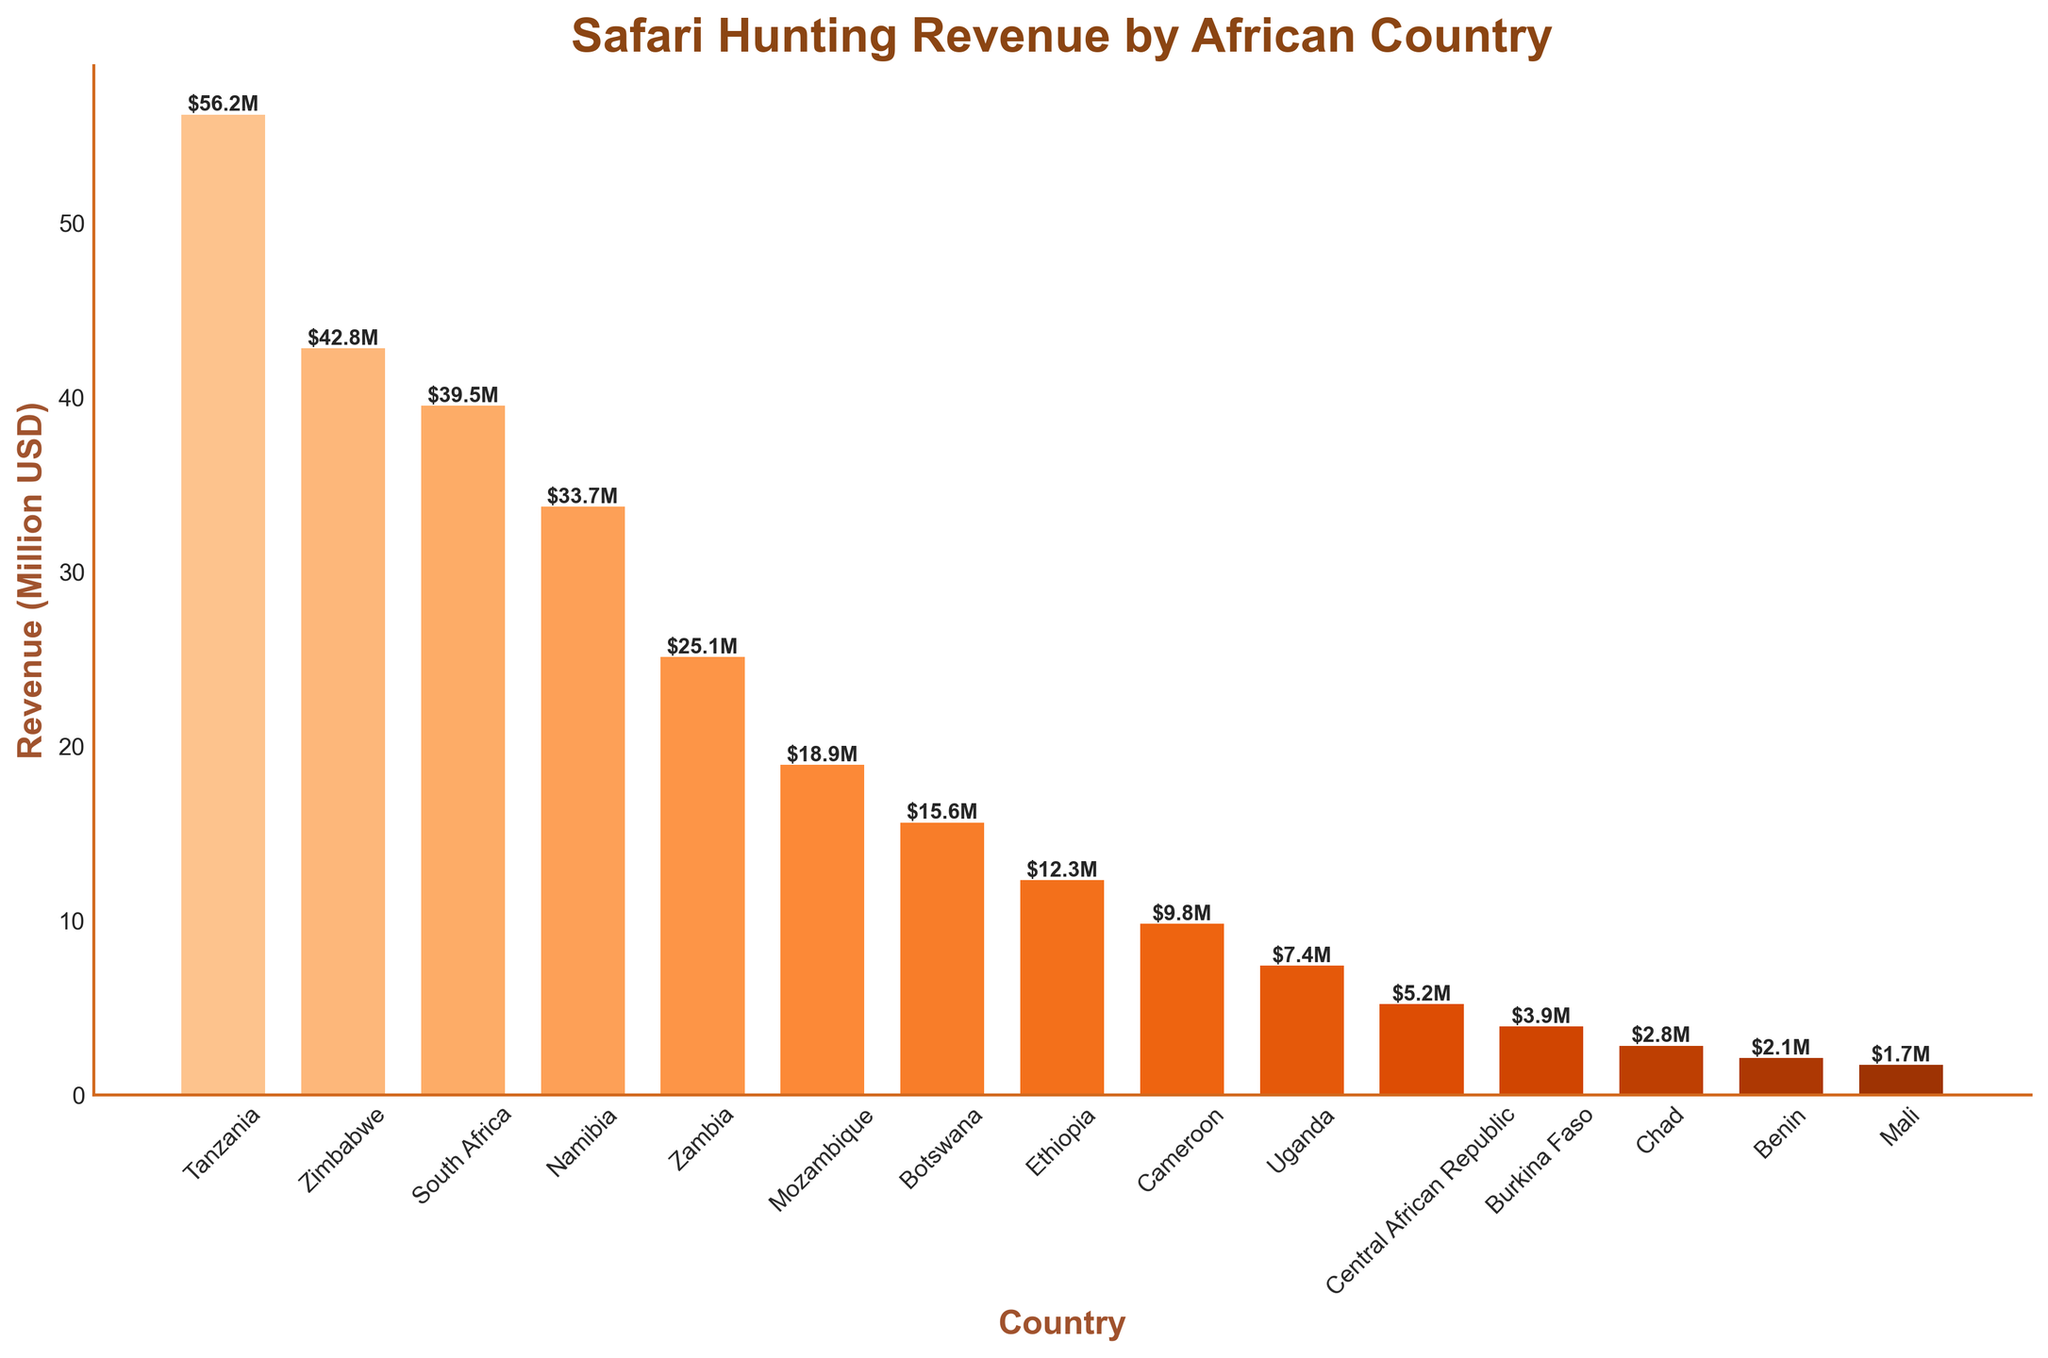Why is Tanzania's bar the tallest? Tanzania's bar is the tallest because it has the highest Safari Hunting Revenue among the listed African countries. According to the data, Tanzania's revenue is 56.2 million USD, which is the largest value in the dataset.
Answer: It has the highest revenue Which country has the lowest safari hunting revenue? The country with the shortest bar represents the lowest safari hunting revenue. According to the data, Mali has the lowest revenue of 1.7 million USD.
Answer: Mali What is the total safari hunting revenue for Tanzania and Zimbabwe combined? Add the revenues for Tanzania and Zimbabwe from the data. Tanzania has 56.2 million USD, and Zimbabwe has 42.8 million USD. The total is 56.2 + 42.8 = 99.0 million USD.
Answer: 99.0 million USD How much more revenue does Tanzania generate compared to Uganda? Subtract Uganda's revenue from Tanzania's revenue. Tanzania has 56.2 million USD and Uganda has 7.4 million USD. So, 56.2 - 7.4 = 48.8 million USD.
Answer: 48.8 million USD What is the average safari hunting revenue for the top three countries? Sum the revenues for Tanzania, Zimbabwe, and South Africa, and then divide by 3. Total: 56.2 + 42.8 + 39.5 = 138.5 million USD. Average: 138.5 / 3 = 46.17 million USD.
Answer: 46.17 million USD Which country earns more from safari hunting, Botswana or Ethiopia? Compare the heights of the bars for Botswana and Ethiopia. Ethiopia has a revenue of 12.3 million USD, while Botswana has a revenue of 15.6 million USD. Botswana's bar is higher.
Answer: Botswana If the safari hunting revenues of Central African Republic and Burkina Faso were combined, where would it rank among the listed countries? Add the revenues of Central African Republic and Burkina Faso. Central African Republic has 5.2 million USD, and Burkina Faso has 3.9 million USD. Combined, this totals 5.2 + 3.9 = 9.1 million USD. Comparing this to other countries, it ranks above Cameroon (9.8 million USD) and below Ethiopia (12.3 million USD).
Answer: Between Ethiopia and Cameroon How does Zambia's revenue compare to that of Mozambique and Namibia combined? First, add the revenues of Mozambique and Namibia. Mozambique has 18.9 million USD, and Namibia has 33.7 million USD. Total: 18.9 + 33.7 = 52.6 million USD. Zambia's revenue is 25.1 million USD. Since 52.6 million is much higher than 25.1 million, Zambia's revenue is less.
Answer: Lower How many countries have a safari hunting revenue above 30 million USD? Identify the countries whose bars exceed the 30 million USD mark. Tanzania, Zimbabwe, South Africa, Namibia, and Zambia each have revenues above 30 million USD, totaling 5 countries.
Answer: 5 What is the combined revenue of all countries with less than 10 million USD in safari hunting revenue? Sum the revenues of countries with less than 10 million USD. These are Cameroon (9.8), Uganda (7.4), Central African Republic (5.2), Burkina Faso (3.9), Chad (2.8), Benin (2.1), and Mali (1.7). Total: 9.8 + 7.4 + 5.2 + 3.9 + 2.8 + 2.1 + 1.7 = 32.9 million USD.
Answer: 32.9 million USD 